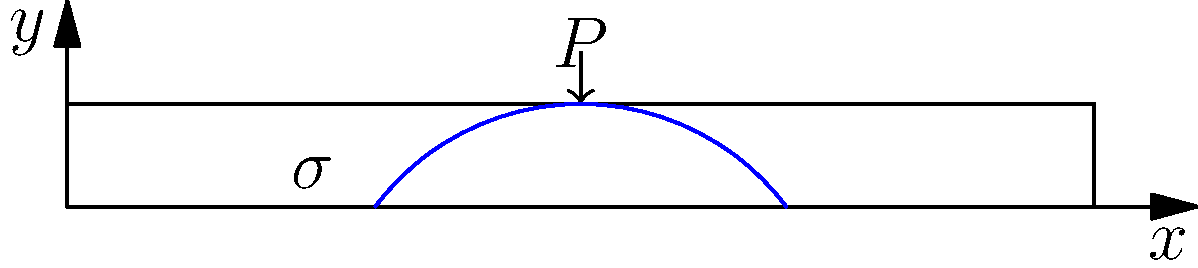In a concrete beam subjected to a point load $P$ at its center, the stress distribution resembles the shape of a parabola. What Italian term, often used in wine tasting, could metaphorically describe this curved stress pattern, and how does it relate to the etymology of structural engineering terms? Let's approach this question step-by-step:

1. The stress distribution in a concrete beam under a point load typically follows a parabolic shape, as shown in the diagram.

2. In Italian wine tasting, the term "arco" is used to describe the progression of flavors from start to finish. This word means "arc" or "bow" in English.

3. The parabolic stress distribution in the beam forms an arc-like shape, similar to the concept of "arco" in wine tasting.

4. Etymologically, the word "arc" comes from the Latin "arcus," which means "bow" or "arch." This root is shared in both Italian and English.

5. In structural engineering, we use terms like "arch" and "arcade" to describe curved structural elements. These terms also derive from the Latin "arcus."

6. The stress distribution in the beam, forming an arc-like shape, can be metaphorically described as the "arco dello stress" (stress arc) in Italian.

7. This connection between the wine tasting term and the structural behavior highlights the interesting cross-pollination of vocabulary between different fields, especially when considering their shared Latin roots.
Answer: Arco (stress arc) 